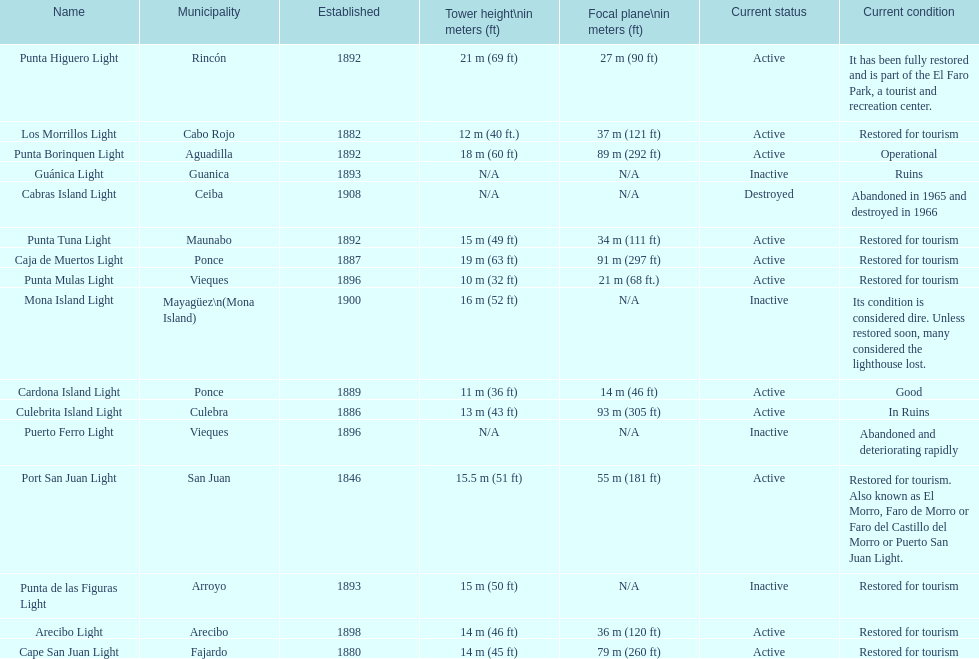What is the tallest tower in existence? Punta Higuero Light. 